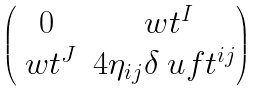Convert formula to latex. <formula><loc_0><loc_0><loc_500><loc_500>\begin{pmatrix} 0 & \ w t ^ { I } \\ \ w t ^ { J } & 4 \eta _ { i j } \delta \ u f t ^ { i j } \end{pmatrix}</formula> 